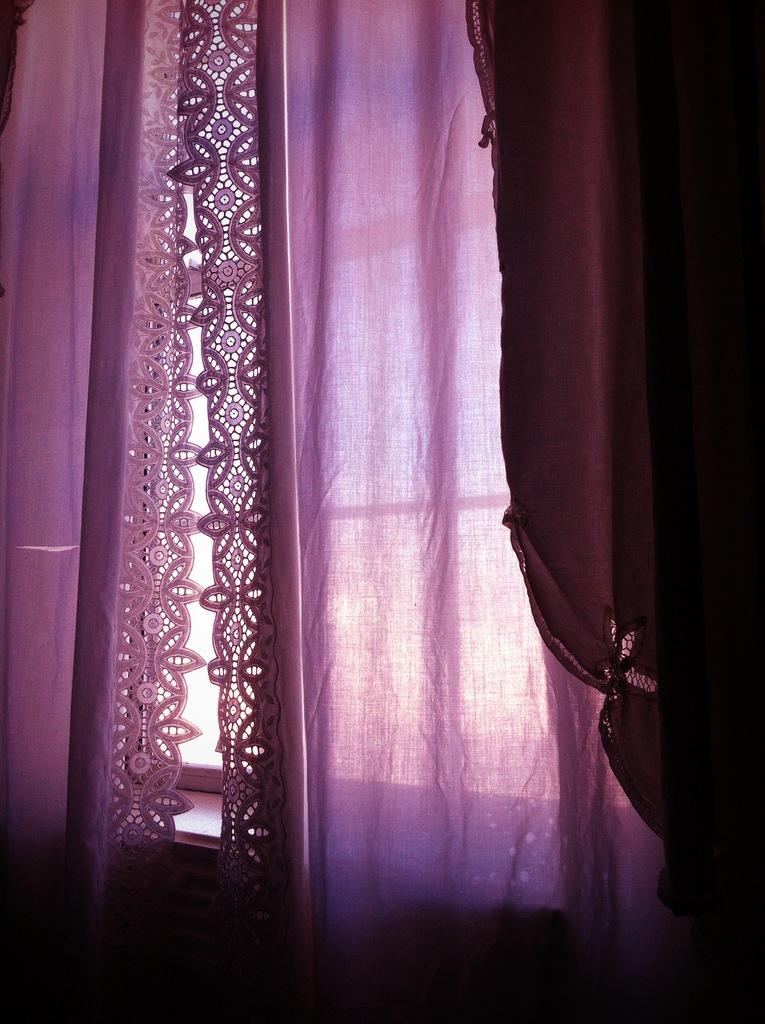What is located in the center of the image? There is a window in the center of the image. Is there any window treatment present in the image? Yes, there is a curtain associated with the window. What type of rake is being used to clean the goose in the image? There is no goose or rake present in the image; it only features a window and a curtain. 